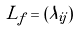Convert formula to latex. <formula><loc_0><loc_0><loc_500><loc_500>L _ { f } = ( \lambda _ { i j } )</formula> 